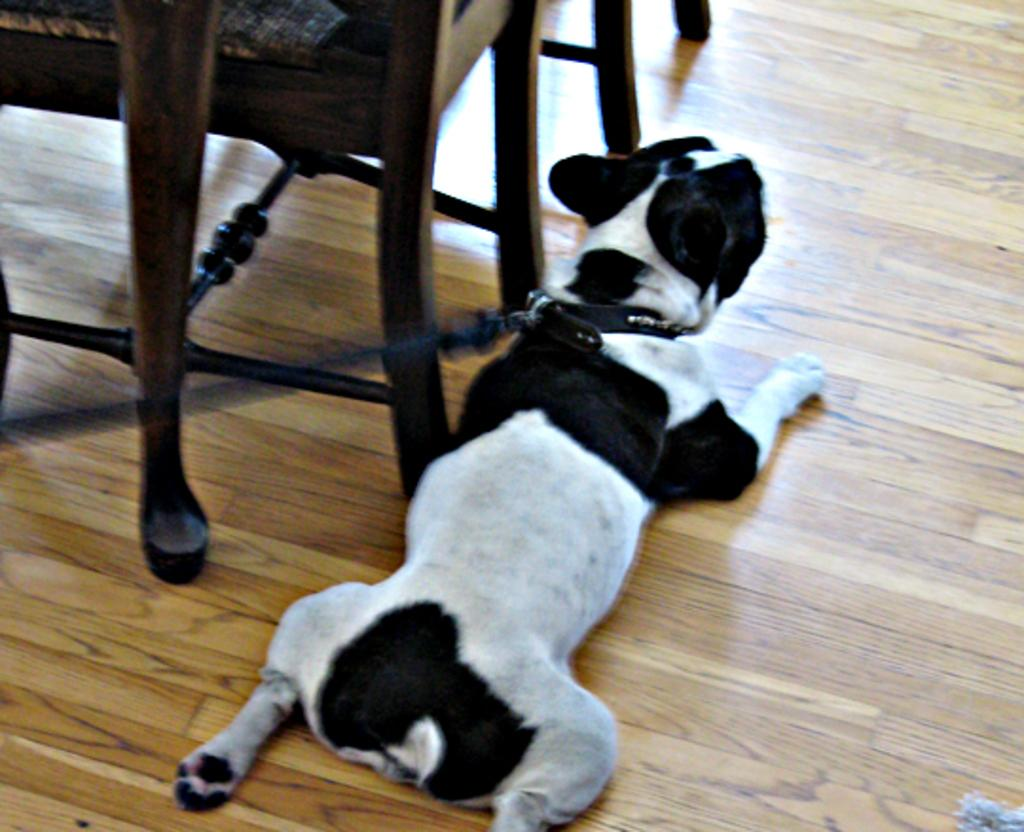What animal is present in the image? There is a dog in the image. How is the dog positioned in relation to other objects? The dog is lying beside a chair. What is the dog's current state or condition? The dog is tied. What other piece of furniture is visible in the image? There is a table in the image. What type of food is the dog eating in the image? There is no food present in the image, and the dog is not shown eating anything. 